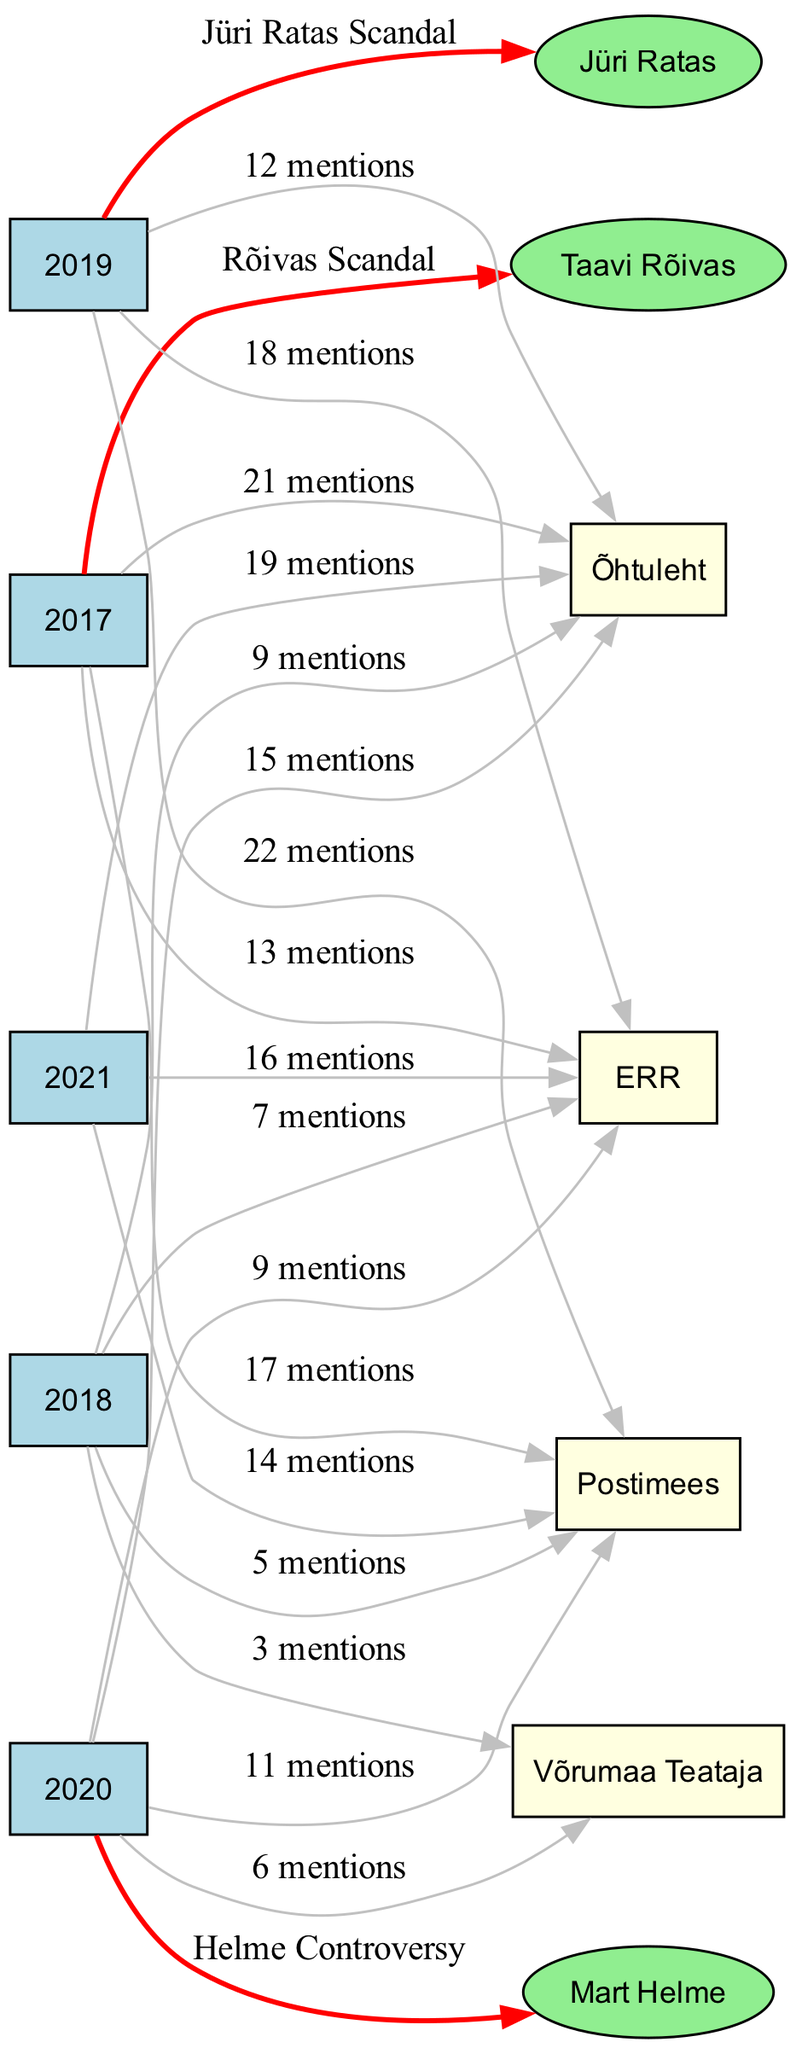What was the total number of mentions for Jüri Ratas in 2019? In 2019, Jüri Ratas is connected to the node with the label "Jüri Ratas Scandal," with an edge showing "Jüri Ratas Scandal" and no specific mention count is linked to it directly; however, the overall mentions for the media outlets in that year are listed. Combined mentions from all media outlets give 52 mentions in total (22 Postimees + 18 ERR + 12 Õhtuleht).
Answer: 52 mentions Which media outlet had the highest mentions in 2017? The diagram shows multiple connections from the year 2017, with Postimees showing "17 mentions," ERR showing "13 mentions," and Õhtuleht showing "21 mentions." Among these, Õhtuleht has the highest mention count.
Answer: Õhtuleht How many times was Mart Helme mentioned in the media overall? The diagram contains data for Mart Helme, which is connected to the year 2020 with "Helme Controversy." The total mentioned count across all edges for him is directly seen in 2020: represented once as "Helme Controversy." No specific counts are combined from other years for him.
Answer: 1 mention Which year had the least media coverage for political scandals? By analyzing the mentions across all years, 2018 stands out with fewer total mentions (5 Postimees + 7 ERR + 9 Õhtuleht + 3 Võrumaa Teataja = 24 mentions), which is less than any other year.
Answer: 2018 Which politician is associated with the most media outlets based on mentions? Taavi Rõivas is connected to 2017 with "Rõivas Scandal," but only Postimees, ERR, and Õhtuleht mentioned him that year. Jüri Ratas is linked in 2019 and was mentioned as well but recorded in more than one outlet. Summarizing data will show Jüri Ratas associated in mentions across his year, giving him a broader reach overall as he appears both in mentions and has connections. Comparison identifies Jüri Ratas as featuring prominently in multiple scenarios.
Answer: Jüri Ratas What was the number of mentions for ERR in the year 2021? The edge connecting from 2021 to ERR indicates "16 mentions," clearly stating the number of times this outlet covered political issues related to that year.
Answer: 16 mentions 